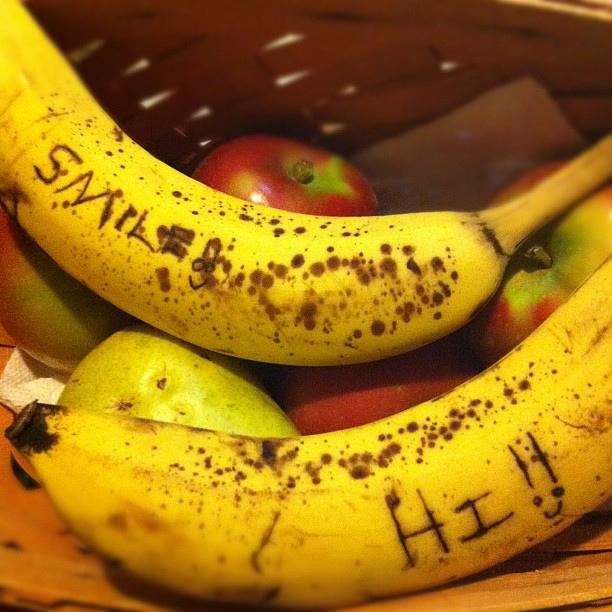What animal do the spots on the banana most resemble? Please explain your reasoning. giraffe. The animal in question does have spots and is yellow. 